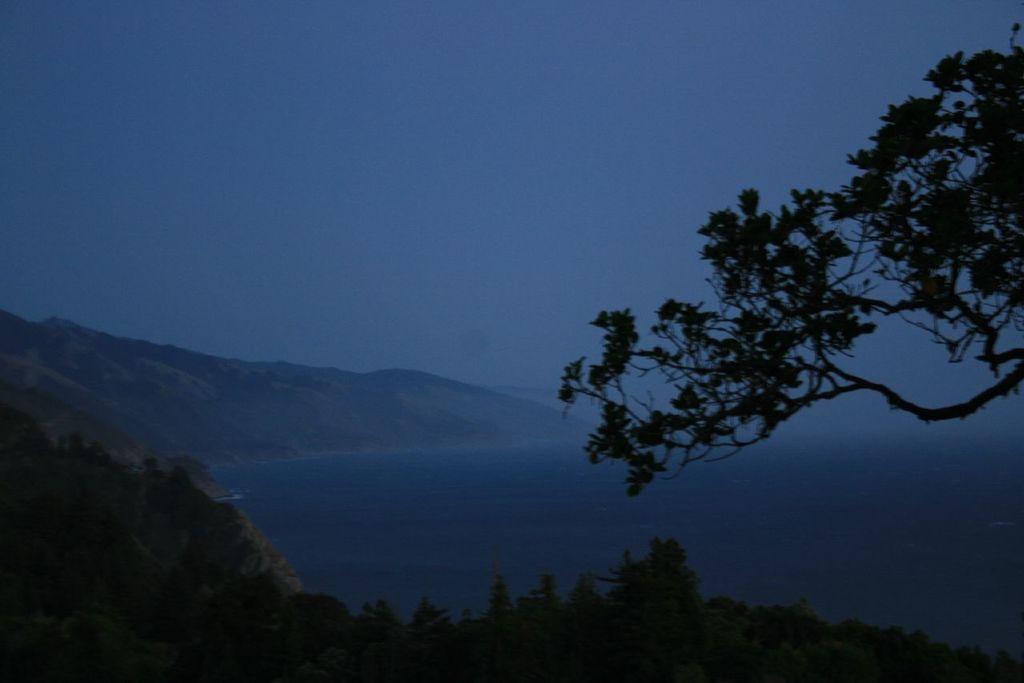Describe this image in one or two sentences. In this image I can see few trees which are green in color, the water and few mountains. In the background I can see the sky. 